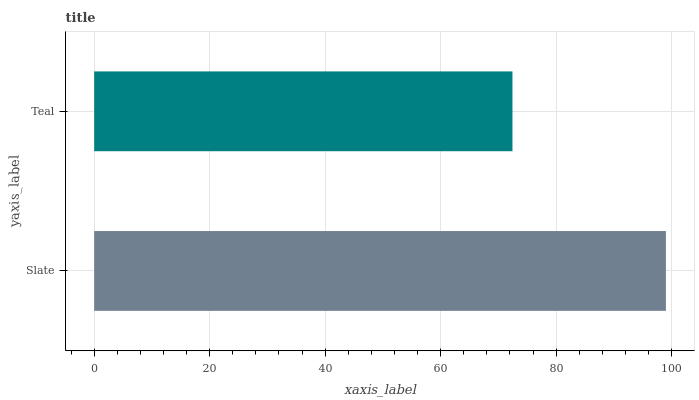Is Teal the minimum?
Answer yes or no. Yes. Is Slate the maximum?
Answer yes or no. Yes. Is Teal the maximum?
Answer yes or no. No. Is Slate greater than Teal?
Answer yes or no. Yes. Is Teal less than Slate?
Answer yes or no. Yes. Is Teal greater than Slate?
Answer yes or no. No. Is Slate less than Teal?
Answer yes or no. No. Is Slate the high median?
Answer yes or no. Yes. Is Teal the low median?
Answer yes or no. Yes. Is Teal the high median?
Answer yes or no. No. Is Slate the low median?
Answer yes or no. No. 